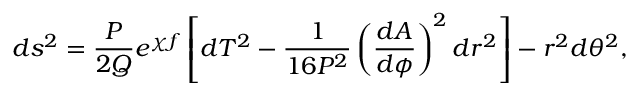Convert formula to latex. <formula><loc_0><loc_0><loc_500><loc_500>d s ^ { 2 } = \frac { P } { 2 Q } e ^ { \chi f } \left [ d T ^ { 2 } - \frac { 1 } { 1 6 P ^ { 2 } } \left ( \frac { d A } { d \phi } \right ) ^ { 2 } d r ^ { 2 } \right ] - r ^ { 2 } d \theta ^ { 2 } ,</formula> 